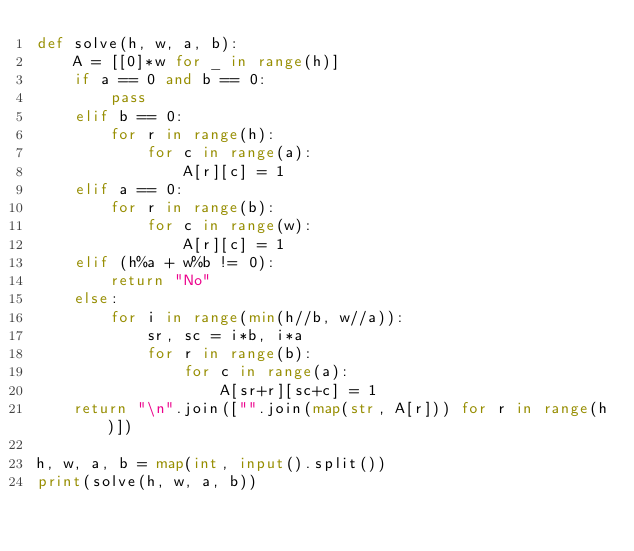<code> <loc_0><loc_0><loc_500><loc_500><_Python_>def solve(h, w, a, b):
    A = [[0]*w for _ in range(h)]
    if a == 0 and b == 0:
        pass
    elif b == 0:
        for r in range(h):
            for c in range(a):
                A[r][c] = 1
    elif a == 0:
        for r in range(b):
            for c in range(w):
                A[r][c] = 1
    elif (h%a + w%b != 0):
        return "No"
    else:
        for i in range(min(h//b, w//a)):
            sr, sc = i*b, i*a
            for r in range(b):
                for c in range(a):
                    A[sr+r][sc+c] = 1
    return "\n".join(["".join(map(str, A[r])) for r in range(h)])

h, w, a, b = map(int, input().split())
print(solve(h, w, a, b))</code> 